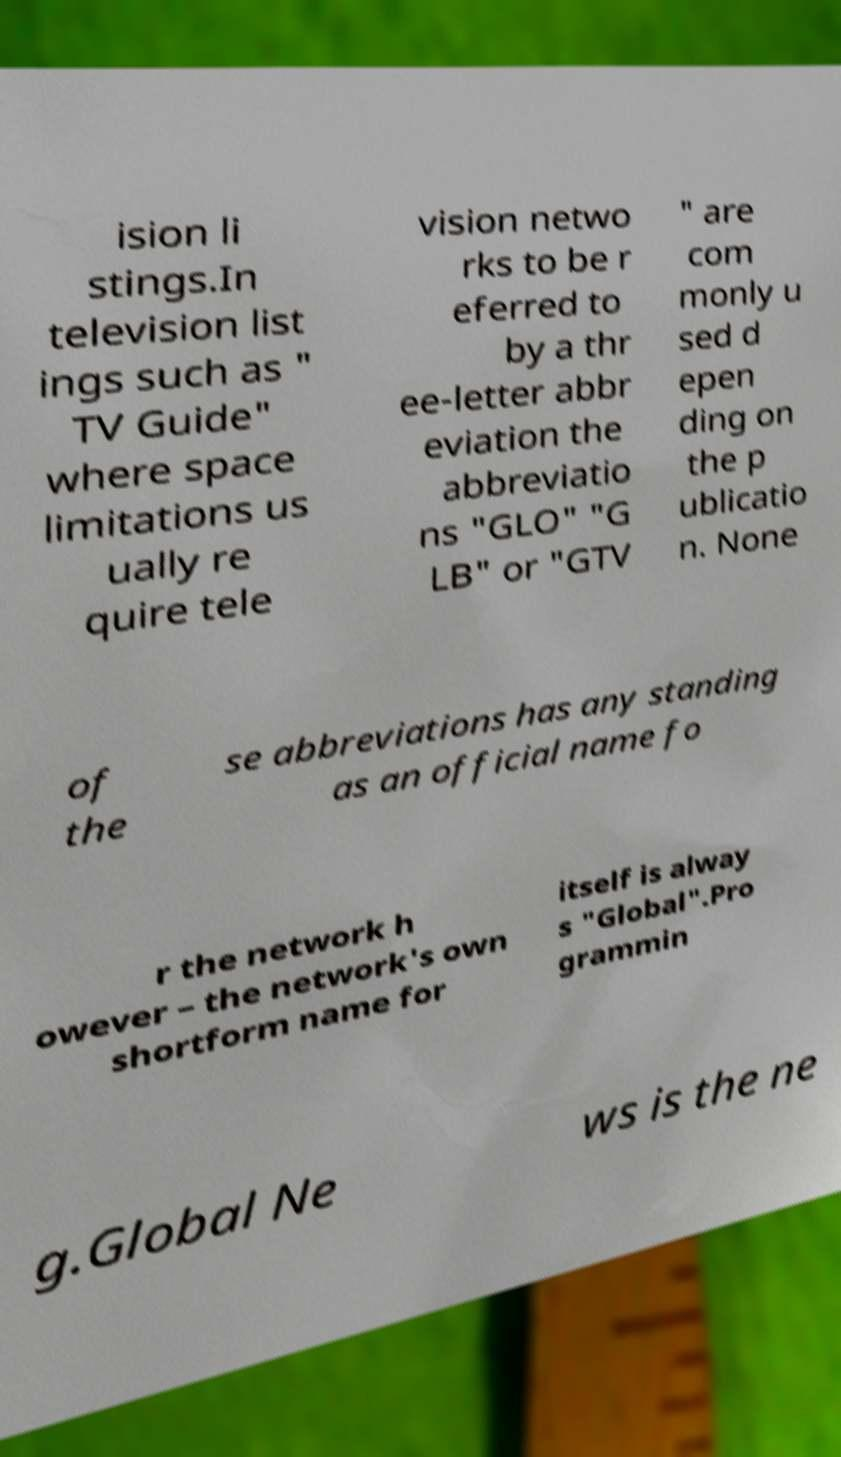Can you read and provide the text displayed in the image?This photo seems to have some interesting text. Can you extract and type it out for me? ision li stings.In television list ings such as " TV Guide" where space limitations us ually re quire tele vision netwo rks to be r eferred to by a thr ee-letter abbr eviation the abbreviatio ns "GLO" "G LB" or "GTV " are com monly u sed d epen ding on the p ublicatio n. None of the se abbreviations has any standing as an official name fo r the network h owever – the network's own shortform name for itself is alway s "Global".Pro grammin g.Global Ne ws is the ne 